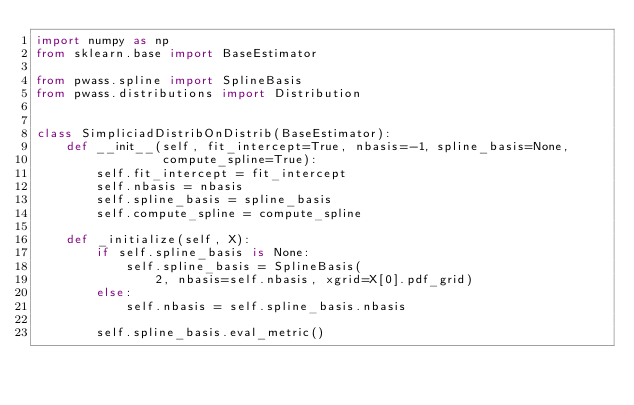Convert code to text. <code><loc_0><loc_0><loc_500><loc_500><_Python_>import numpy as np
from sklearn.base import BaseEstimator

from pwass.spline import SplineBasis
from pwass.distributions import Distribution


class SimpliciadDistribOnDistrib(BaseEstimator):
    def __init__(self, fit_intercept=True, nbasis=-1, spline_basis=None,
                 compute_spline=True):
        self.fit_intercept = fit_intercept
        self.nbasis = nbasis
        self.spline_basis = spline_basis
        self.compute_spline = compute_spline

    def _initialize(self, X):
        if self.spline_basis is None:
            self.spline_basis = SplineBasis(
                2, nbasis=self.nbasis, xgrid=X[0].pdf_grid)
        else:
            self.nbasis = self.spline_basis.nbasis

        self.spline_basis.eval_metric()
</code> 